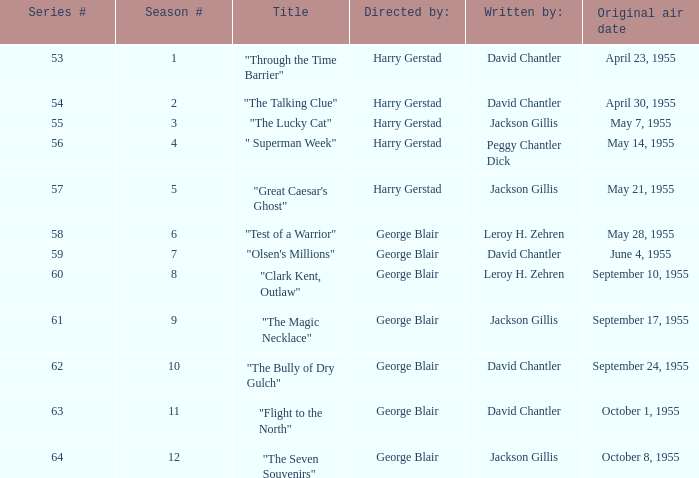Who composed "the magic necklace"? Jackson Gillis. 